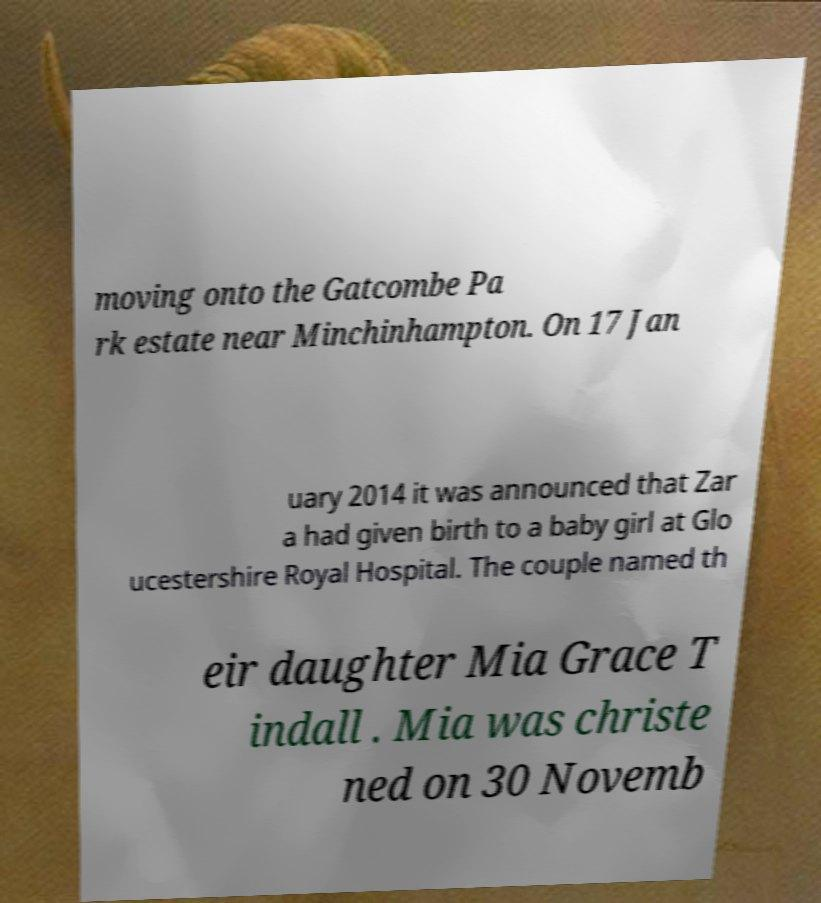Can you read and provide the text displayed in the image?This photo seems to have some interesting text. Can you extract and type it out for me? moving onto the Gatcombe Pa rk estate near Minchinhampton. On 17 Jan uary 2014 it was announced that Zar a had given birth to a baby girl at Glo ucestershire Royal Hospital. The couple named th eir daughter Mia Grace T indall . Mia was christe ned on 30 Novemb 